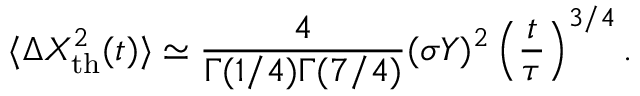<formula> <loc_0><loc_0><loc_500><loc_500>\langle \Delta X _ { t h } ^ { 2 } ( t ) \rangle \simeq \frac { 4 } { \Gamma ( 1 / 4 ) \Gamma ( 7 / 4 ) } ( \sigma Y ) ^ { 2 } \left ( \frac { t } { \tau } \right ) ^ { 3 / 4 } .</formula> 